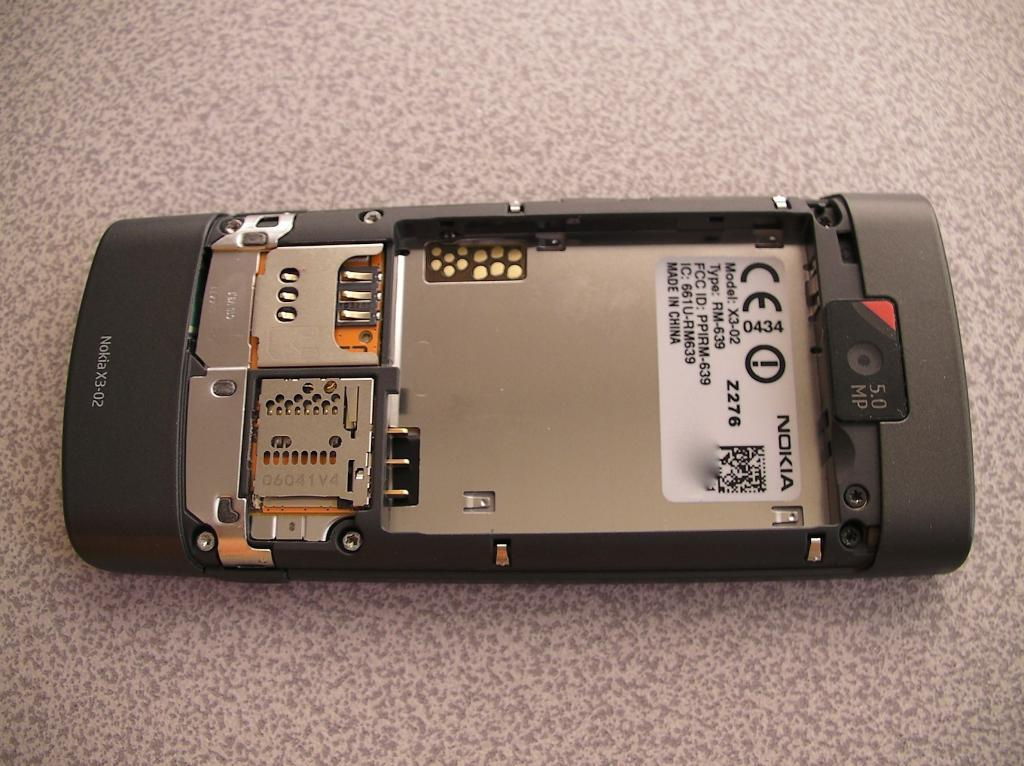What electronic device is visible in the image? There is a mobile phone in the image. What is the status of the mobile phone's battery? The mobile phone has no battery. Are there any SIM cards present in the image? No, there are no SIM cards in the image. What type of storage device is present in the image? There is a memory card in the image. Where are the mobile phone, SIM cards, and memory card located? They are all on a platform. What type of plant is growing under the memory card in the image? There is no plant present in the image, and the memory card is not covering any plant. 